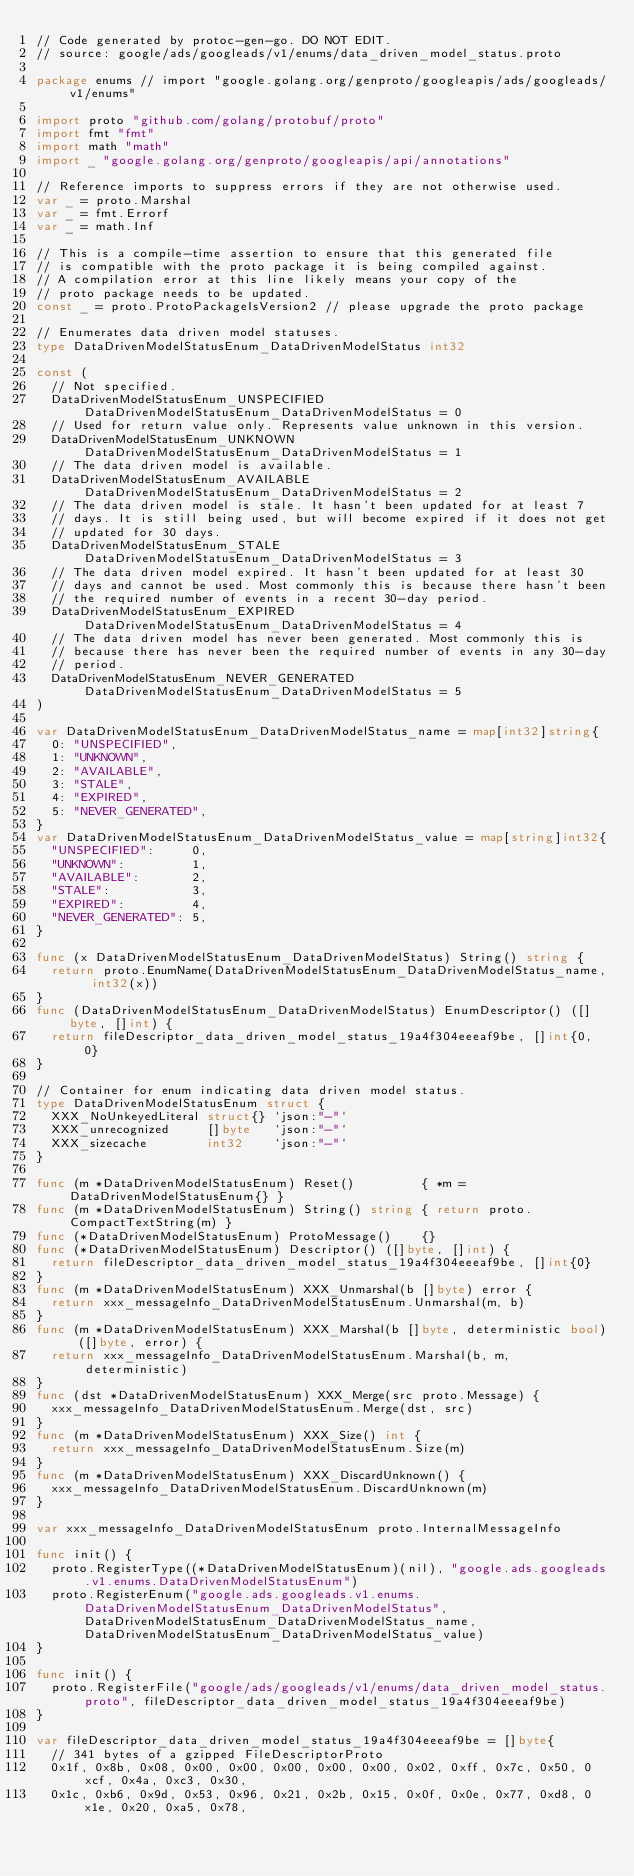<code> <loc_0><loc_0><loc_500><loc_500><_Go_>// Code generated by protoc-gen-go. DO NOT EDIT.
// source: google/ads/googleads/v1/enums/data_driven_model_status.proto

package enums // import "google.golang.org/genproto/googleapis/ads/googleads/v1/enums"

import proto "github.com/golang/protobuf/proto"
import fmt "fmt"
import math "math"
import _ "google.golang.org/genproto/googleapis/api/annotations"

// Reference imports to suppress errors if they are not otherwise used.
var _ = proto.Marshal
var _ = fmt.Errorf
var _ = math.Inf

// This is a compile-time assertion to ensure that this generated file
// is compatible with the proto package it is being compiled against.
// A compilation error at this line likely means your copy of the
// proto package needs to be updated.
const _ = proto.ProtoPackageIsVersion2 // please upgrade the proto package

// Enumerates data driven model statuses.
type DataDrivenModelStatusEnum_DataDrivenModelStatus int32

const (
	// Not specified.
	DataDrivenModelStatusEnum_UNSPECIFIED DataDrivenModelStatusEnum_DataDrivenModelStatus = 0
	// Used for return value only. Represents value unknown in this version.
	DataDrivenModelStatusEnum_UNKNOWN DataDrivenModelStatusEnum_DataDrivenModelStatus = 1
	// The data driven model is available.
	DataDrivenModelStatusEnum_AVAILABLE DataDrivenModelStatusEnum_DataDrivenModelStatus = 2
	// The data driven model is stale. It hasn't been updated for at least 7
	// days. It is still being used, but will become expired if it does not get
	// updated for 30 days.
	DataDrivenModelStatusEnum_STALE DataDrivenModelStatusEnum_DataDrivenModelStatus = 3
	// The data driven model expired. It hasn't been updated for at least 30
	// days and cannot be used. Most commonly this is because there hasn't been
	// the required number of events in a recent 30-day period.
	DataDrivenModelStatusEnum_EXPIRED DataDrivenModelStatusEnum_DataDrivenModelStatus = 4
	// The data driven model has never been generated. Most commonly this is
	// because there has never been the required number of events in any 30-day
	// period.
	DataDrivenModelStatusEnum_NEVER_GENERATED DataDrivenModelStatusEnum_DataDrivenModelStatus = 5
)

var DataDrivenModelStatusEnum_DataDrivenModelStatus_name = map[int32]string{
	0: "UNSPECIFIED",
	1: "UNKNOWN",
	2: "AVAILABLE",
	3: "STALE",
	4: "EXPIRED",
	5: "NEVER_GENERATED",
}
var DataDrivenModelStatusEnum_DataDrivenModelStatus_value = map[string]int32{
	"UNSPECIFIED":     0,
	"UNKNOWN":         1,
	"AVAILABLE":       2,
	"STALE":           3,
	"EXPIRED":         4,
	"NEVER_GENERATED": 5,
}

func (x DataDrivenModelStatusEnum_DataDrivenModelStatus) String() string {
	return proto.EnumName(DataDrivenModelStatusEnum_DataDrivenModelStatus_name, int32(x))
}
func (DataDrivenModelStatusEnum_DataDrivenModelStatus) EnumDescriptor() ([]byte, []int) {
	return fileDescriptor_data_driven_model_status_19a4f304eeeaf9be, []int{0, 0}
}

// Container for enum indicating data driven model status.
type DataDrivenModelStatusEnum struct {
	XXX_NoUnkeyedLiteral struct{} `json:"-"`
	XXX_unrecognized     []byte   `json:"-"`
	XXX_sizecache        int32    `json:"-"`
}

func (m *DataDrivenModelStatusEnum) Reset()         { *m = DataDrivenModelStatusEnum{} }
func (m *DataDrivenModelStatusEnum) String() string { return proto.CompactTextString(m) }
func (*DataDrivenModelStatusEnum) ProtoMessage()    {}
func (*DataDrivenModelStatusEnum) Descriptor() ([]byte, []int) {
	return fileDescriptor_data_driven_model_status_19a4f304eeeaf9be, []int{0}
}
func (m *DataDrivenModelStatusEnum) XXX_Unmarshal(b []byte) error {
	return xxx_messageInfo_DataDrivenModelStatusEnum.Unmarshal(m, b)
}
func (m *DataDrivenModelStatusEnum) XXX_Marshal(b []byte, deterministic bool) ([]byte, error) {
	return xxx_messageInfo_DataDrivenModelStatusEnum.Marshal(b, m, deterministic)
}
func (dst *DataDrivenModelStatusEnum) XXX_Merge(src proto.Message) {
	xxx_messageInfo_DataDrivenModelStatusEnum.Merge(dst, src)
}
func (m *DataDrivenModelStatusEnum) XXX_Size() int {
	return xxx_messageInfo_DataDrivenModelStatusEnum.Size(m)
}
func (m *DataDrivenModelStatusEnum) XXX_DiscardUnknown() {
	xxx_messageInfo_DataDrivenModelStatusEnum.DiscardUnknown(m)
}

var xxx_messageInfo_DataDrivenModelStatusEnum proto.InternalMessageInfo

func init() {
	proto.RegisterType((*DataDrivenModelStatusEnum)(nil), "google.ads.googleads.v1.enums.DataDrivenModelStatusEnum")
	proto.RegisterEnum("google.ads.googleads.v1.enums.DataDrivenModelStatusEnum_DataDrivenModelStatus", DataDrivenModelStatusEnum_DataDrivenModelStatus_name, DataDrivenModelStatusEnum_DataDrivenModelStatus_value)
}

func init() {
	proto.RegisterFile("google/ads/googleads/v1/enums/data_driven_model_status.proto", fileDescriptor_data_driven_model_status_19a4f304eeeaf9be)
}

var fileDescriptor_data_driven_model_status_19a4f304eeeaf9be = []byte{
	// 341 bytes of a gzipped FileDescriptorProto
	0x1f, 0x8b, 0x08, 0x00, 0x00, 0x00, 0x00, 0x00, 0x02, 0xff, 0x7c, 0x50, 0xcf, 0x4a, 0xc3, 0x30,
	0x1c, 0xb6, 0x9d, 0x53, 0x96, 0x21, 0x2b, 0x15, 0x0f, 0x0e, 0x77, 0xd8, 0x1e, 0x20, 0xa5, 0x78,</code> 